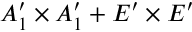<formula> <loc_0><loc_0><loc_500><loc_500>A _ { 1 } ^ { \prime } \times A _ { 1 } ^ { \prime } + E ^ { \prime } \times E ^ { \prime }</formula> 